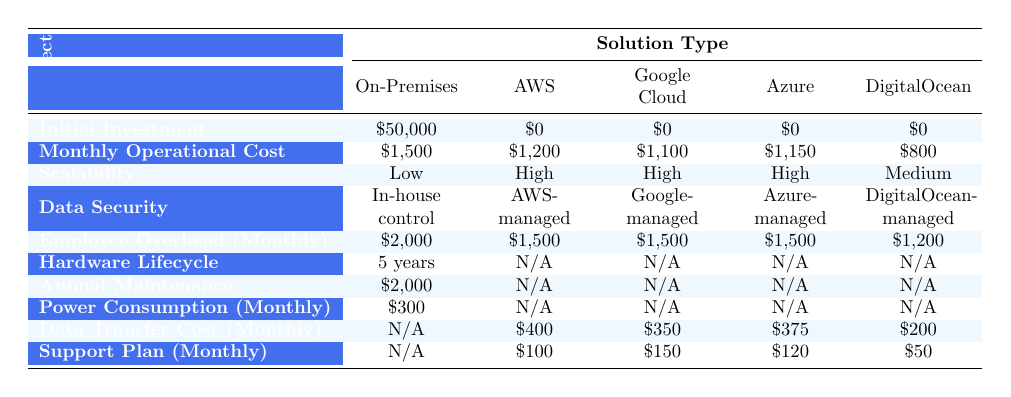What is the initial investment required for on-premises solutions? According to the table, the initial investment for on-premises solutions is provided directly in the row corresponding to it, showing a value of $50,000.
Answer: $50,000 What is the monthly operational cost for DigitalOcean? The monthly operational cost for DigitalOcean can be found in the respective row, which indicates a value of $800.
Answer: $800 Which cloud solution has the highest scalability rating? The scalability ratings for cloud solutions are determined from their respective rows. Both AWS, Google Cloud, and Azure are rated as "High", while DigitalOcean has "Medium", and on-premises has "Low". Hence, the highest scalability rating is shared by AWS, Google Cloud, and Azure.
Answer: AWS, Google Cloud, Azure Is the data security for on-premises solutions managed in-house? The table specifies that the data security for on-premises solutions is indeed "In-house control", confirming this fact.
Answer: Yes What is the difference in monthly operational costs between AWS and Microsoft Azure? To find the difference, we subtract the monthly operational cost of Microsoft Azure ($1,150) from that of AWS ($1,200). The calculation is $1,200 - $1,150, resulting in a difference of $50.
Answer: $50 What is the total monthly cost for AWS, including employee overhead and data transfer costs? The total monthly cost for AWS includes both the monthly operational cost ($1,200) and additional monthly costs for employee overhead ($1,500) and data transfer ($400). Thus, the total is $1,200 + $1,500 + $400 = $3,100.
Answer: $3,100 Does DigitalOcean have a support plan cost per month greater than $100? Checking the support plan cost for DigitalOcean, which is listed as $50, confirms that it is not greater than $100.
Answer: No What is the total annual maintenance cost for on-premises solutions? Since the annual maintenance cost is specified in the table for on-premises solutions as $2,000 per year, this total value stands alone and does not require additional calculations.
Answer: $2,000 What is the average monthly operational cost across all cloud solutions excluding DigitalOcean? To find the average, we first sum the monthly operational costs of the cloud solutions: AWS ($1,200) + Google Cloud ($1,100) + Azure ($1,150) = $3,450. There are 3 solutions, so average = $3,450 / 3 = $1,150.
Answer: $1,150 